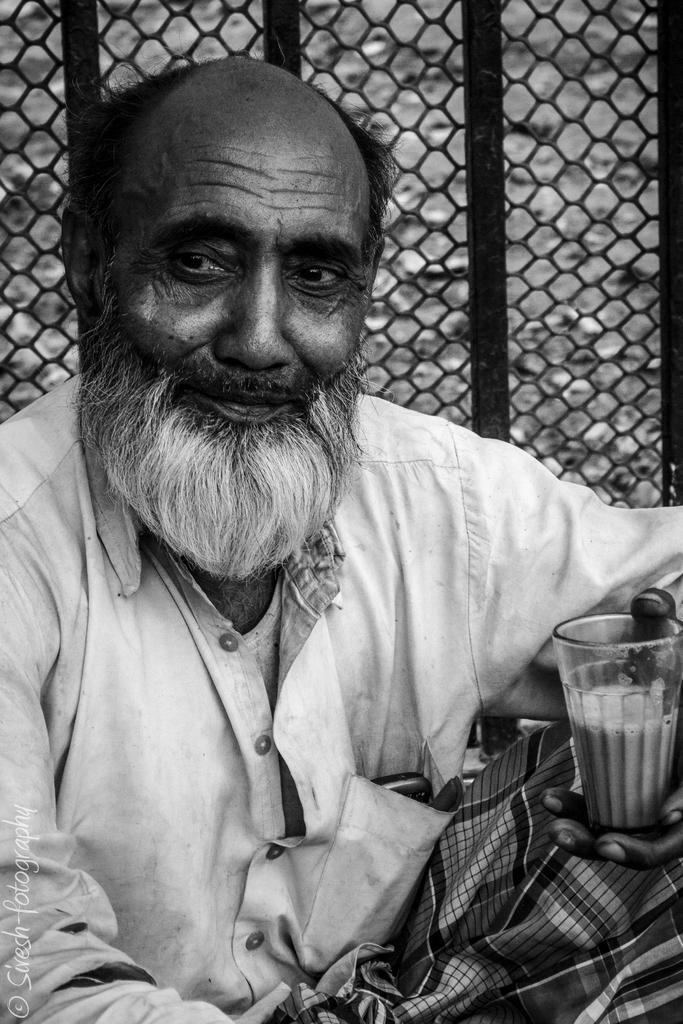What is the color scheme of the image? The image is black and white. What is the man in the image doing? The man is sitting in the image. What is the man holding in his hand? The man is holding a glass in his hand. In which direction is the man looking? The man is looking to the left side. What can be seen in the background of the image? There is a net visible in the background. How many books are on the van in the image? There is no van or books present in the image. What does the man wish for peace in the image? The image does not depict any actions or expressions related to peace. 